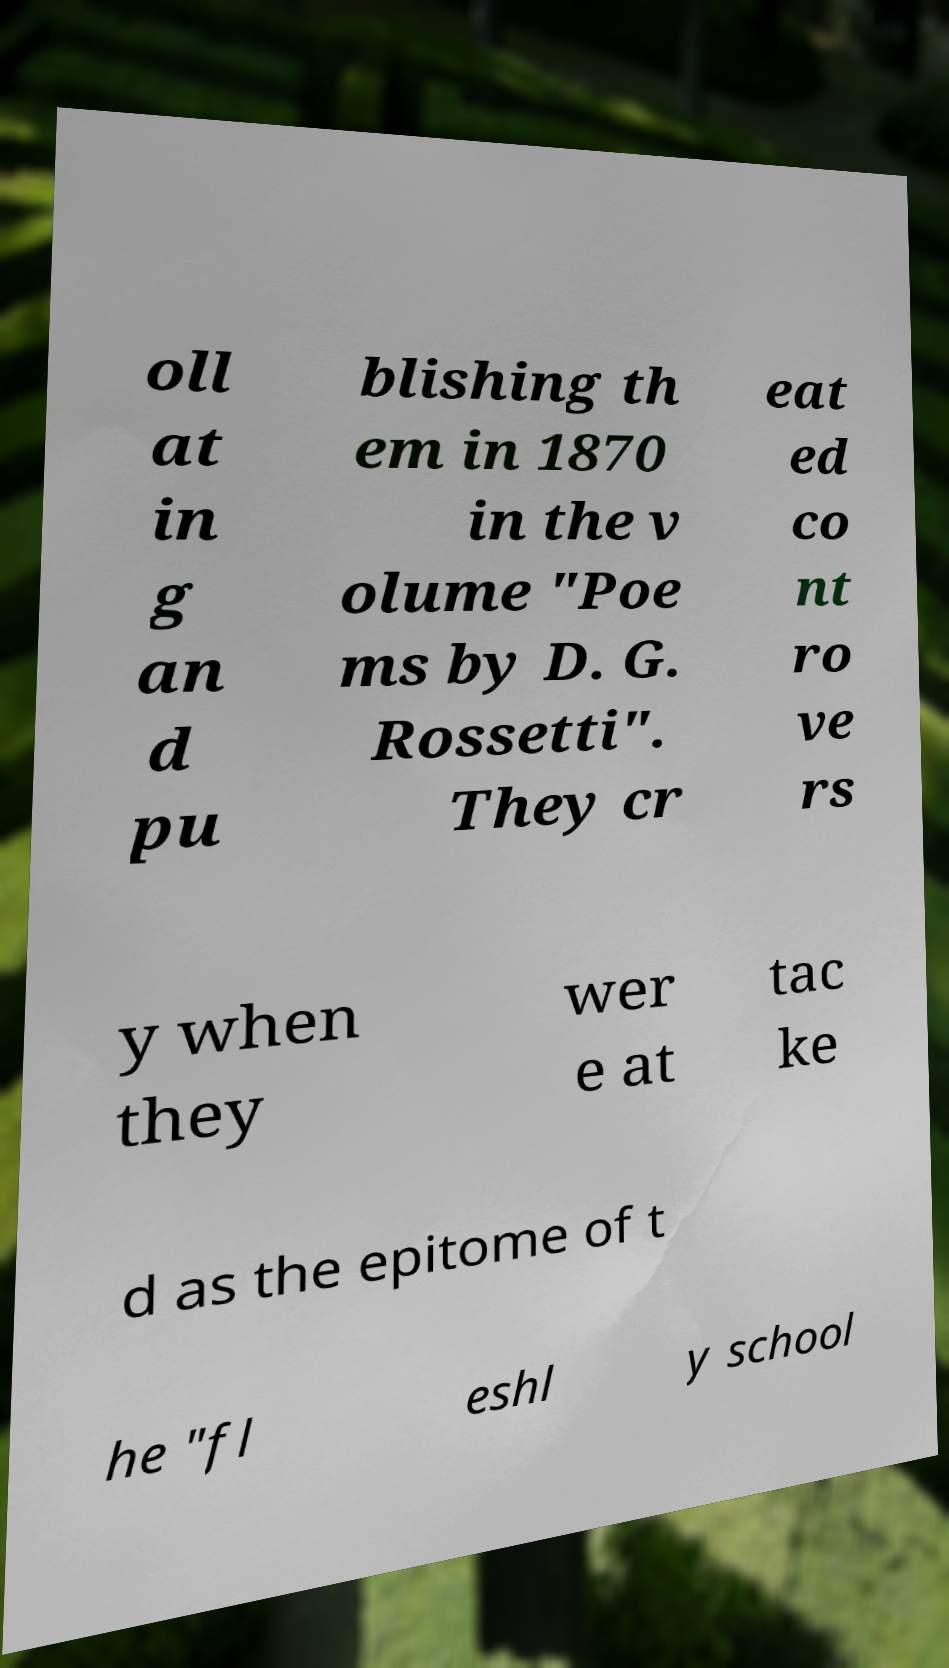For documentation purposes, I need the text within this image transcribed. Could you provide that? oll at in g an d pu blishing th em in 1870 in the v olume "Poe ms by D. G. Rossetti". They cr eat ed co nt ro ve rs y when they wer e at tac ke d as the epitome of t he "fl eshl y school 